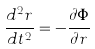<formula> <loc_0><loc_0><loc_500><loc_500>\frac { d ^ { 2 } r } { d t ^ { 2 } } = - \frac { { \partial } { \Phi } } { { \partial } r }</formula> 